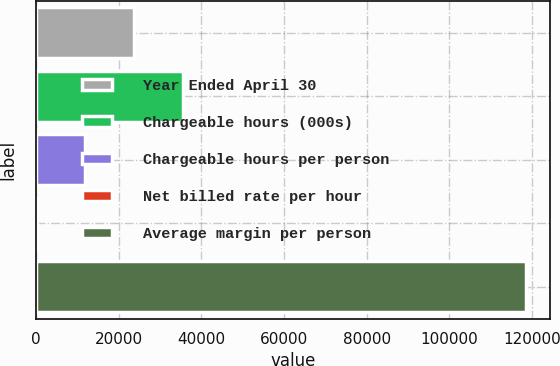<chart> <loc_0><loc_0><loc_500><loc_500><bar_chart><fcel>Year Ended April 30<fcel>Chargeable hours (000s)<fcel>Chargeable hours per person<fcel>Net billed rate per hour<fcel>Average margin per person<nl><fcel>23801.4<fcel>35628.1<fcel>11974.7<fcel>148<fcel>118415<nl></chart> 